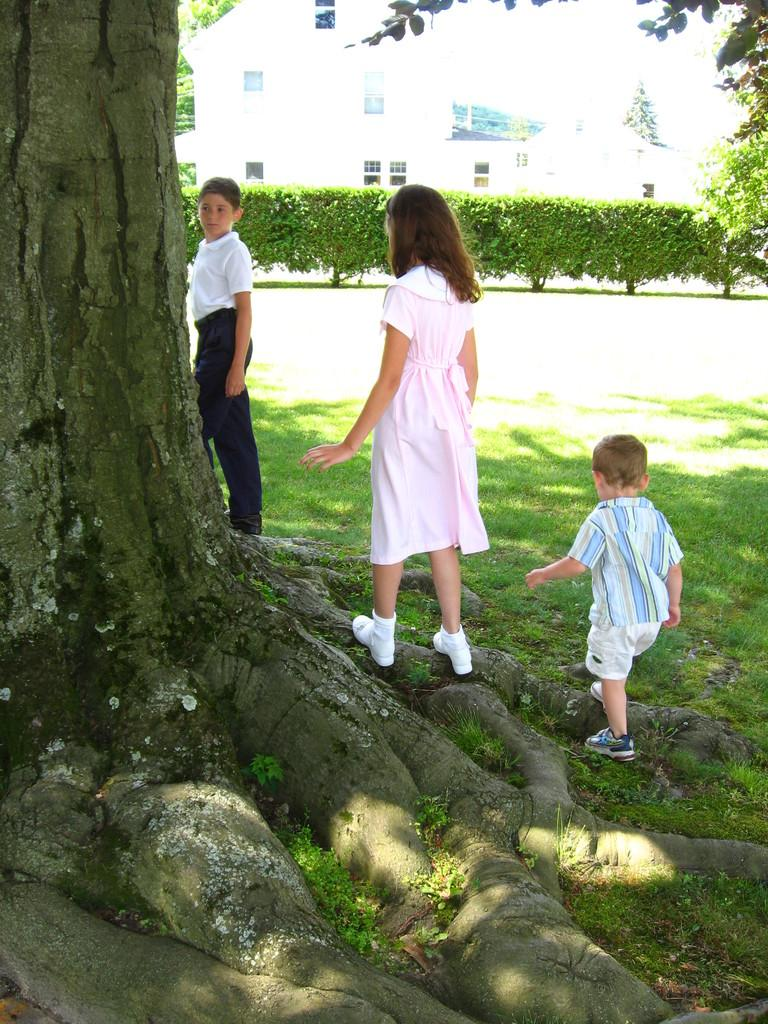What is: What is located in the foreground of the image? There is a tree in the foreground of the image. What can be seen near the tree in the image? There are three children near the tree. What type of wax can be seen melting on the tree in the image? There is no wax present in the image; it features a tree and three children. How many sheep are visible in the image? There are no sheep present in the image. 